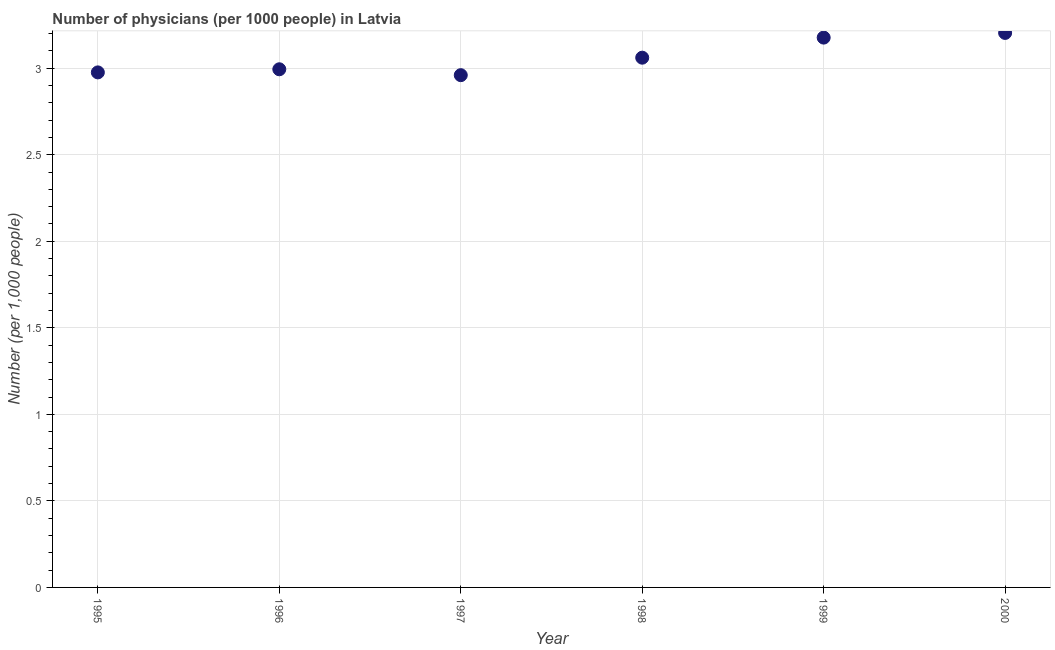What is the number of physicians in 1996?
Provide a succinct answer. 2.99. Across all years, what is the maximum number of physicians?
Keep it short and to the point. 3.2. Across all years, what is the minimum number of physicians?
Your answer should be compact. 2.96. In which year was the number of physicians maximum?
Your response must be concise. 2000. What is the sum of the number of physicians?
Make the answer very short. 18.37. What is the difference between the number of physicians in 1999 and 2000?
Your answer should be very brief. -0.03. What is the average number of physicians per year?
Keep it short and to the point. 3.06. What is the median number of physicians?
Your response must be concise. 3.03. What is the ratio of the number of physicians in 1996 to that in 2000?
Your answer should be very brief. 0.93. Is the number of physicians in 1997 less than that in 1998?
Offer a terse response. Yes. What is the difference between the highest and the second highest number of physicians?
Offer a terse response. 0.03. Is the sum of the number of physicians in 1998 and 2000 greater than the maximum number of physicians across all years?
Offer a very short reply. Yes. What is the difference between the highest and the lowest number of physicians?
Offer a very short reply. 0.24. Does the number of physicians monotonically increase over the years?
Make the answer very short. No. Does the graph contain any zero values?
Make the answer very short. No. Does the graph contain grids?
Offer a very short reply. Yes. What is the title of the graph?
Ensure brevity in your answer.  Number of physicians (per 1000 people) in Latvia. What is the label or title of the X-axis?
Your response must be concise. Year. What is the label or title of the Y-axis?
Ensure brevity in your answer.  Number (per 1,0 people). What is the Number (per 1,000 people) in 1995?
Make the answer very short. 2.98. What is the Number (per 1,000 people) in 1996?
Your answer should be very brief. 2.99. What is the Number (per 1,000 people) in 1997?
Give a very brief answer. 2.96. What is the Number (per 1,000 people) in 1998?
Provide a succinct answer. 3.06. What is the Number (per 1,000 people) in 1999?
Offer a terse response. 3.18. What is the Number (per 1,000 people) in 2000?
Offer a terse response. 3.2. What is the difference between the Number (per 1,000 people) in 1995 and 1996?
Your response must be concise. -0.02. What is the difference between the Number (per 1,000 people) in 1995 and 1997?
Your response must be concise. 0.02. What is the difference between the Number (per 1,000 people) in 1995 and 1998?
Provide a short and direct response. -0.09. What is the difference between the Number (per 1,000 people) in 1995 and 1999?
Offer a very short reply. -0.2. What is the difference between the Number (per 1,000 people) in 1995 and 2000?
Offer a terse response. -0.23. What is the difference between the Number (per 1,000 people) in 1996 and 1997?
Provide a short and direct response. 0.03. What is the difference between the Number (per 1,000 people) in 1996 and 1998?
Make the answer very short. -0.07. What is the difference between the Number (per 1,000 people) in 1996 and 1999?
Offer a very short reply. -0.18. What is the difference between the Number (per 1,000 people) in 1996 and 2000?
Offer a terse response. -0.21. What is the difference between the Number (per 1,000 people) in 1997 and 1998?
Make the answer very short. -0.1. What is the difference between the Number (per 1,000 people) in 1997 and 1999?
Make the answer very short. -0.22. What is the difference between the Number (per 1,000 people) in 1997 and 2000?
Your response must be concise. -0.24. What is the difference between the Number (per 1,000 people) in 1998 and 1999?
Provide a succinct answer. -0.12. What is the difference between the Number (per 1,000 people) in 1998 and 2000?
Your answer should be compact. -0.14. What is the difference between the Number (per 1,000 people) in 1999 and 2000?
Your answer should be compact. -0.03. What is the ratio of the Number (per 1,000 people) in 1995 to that in 1996?
Keep it short and to the point. 0.99. What is the ratio of the Number (per 1,000 people) in 1995 to that in 1998?
Keep it short and to the point. 0.97. What is the ratio of the Number (per 1,000 people) in 1995 to that in 1999?
Ensure brevity in your answer.  0.94. What is the ratio of the Number (per 1,000 people) in 1995 to that in 2000?
Give a very brief answer. 0.93. What is the ratio of the Number (per 1,000 people) in 1996 to that in 1999?
Keep it short and to the point. 0.94. What is the ratio of the Number (per 1,000 people) in 1996 to that in 2000?
Offer a very short reply. 0.93. What is the ratio of the Number (per 1,000 people) in 1997 to that in 1998?
Ensure brevity in your answer.  0.97. What is the ratio of the Number (per 1,000 people) in 1997 to that in 1999?
Your response must be concise. 0.93. What is the ratio of the Number (per 1,000 people) in 1997 to that in 2000?
Keep it short and to the point. 0.92. What is the ratio of the Number (per 1,000 people) in 1998 to that in 2000?
Your answer should be compact. 0.95. 